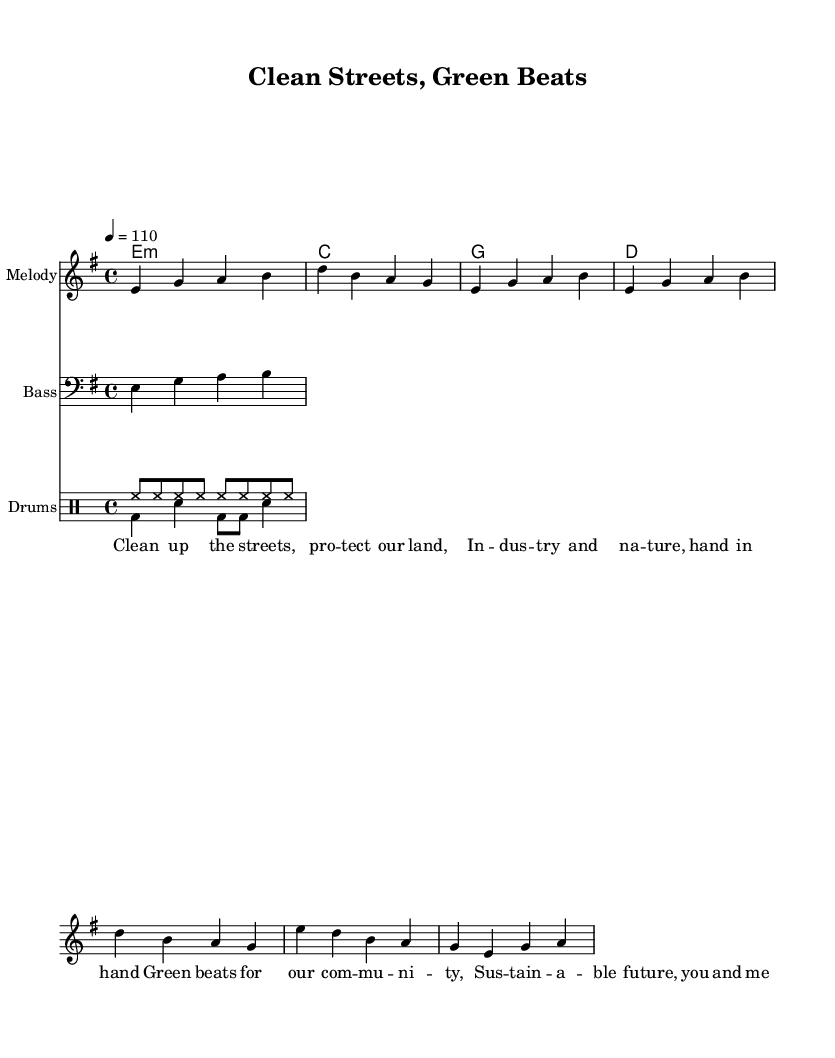What is the key signature of this music? The key signature is E minor, which contains one sharp. This can be found in the global context where the key is indicated as "e \minor".
Answer: E minor What is the time signature of the piece? The time signature is 4/4, which means there are four beats in each measure and the quarter note gets one beat. This is specified at the beginning of the global settings with "\time 4/4".
Answer: 4/4 What is the tempo marking for this piece? The tempo marking is 110 beats per minute, indicated by "\tempo 4 = 110" in the global section, meaning the quarter note is played at this speed.
Answer: 110 How many measures are in the melody section? The melody section consists of three distinct parts: an introduction, a verse, and a chorus. Counting the measures in the melodyIntro, melodyVerse, and melodyChorus, we find there are a total of seven measures in the melody.
Answer: 7 What is the main theme of the lyrics? The lyrics focus on cleaning up the streets and protecting the environment, emphasizing community involvement and sustainability. This is evident from phrases like "Clean up the streets" and "Sustainable future," reflecting a socially conscious theme.
Answer: Environmental protection How does the drum pattern contribute to the funk genre? The drum patterns include a consistent hi-hat in the "up" pattern, which provides a steady rhythmic drive, typical of funk music, while the "down" pattern includes a bass drum and snare combination that creates syncopation. This interplay adds groove and is essential in funk music's rhythmic structure.
Answer: Syncopation What is the function of the bass line in this piece? The bass line supports the harmony established by the chord progression and provides a rhythmic foundation that aligns with the drum patterns, enhancing the funky feel of the music. It plays a repetitive, catchy line that draws listeners into the groove, which is essential in funk music.
Answer: Rhythmic foundation 